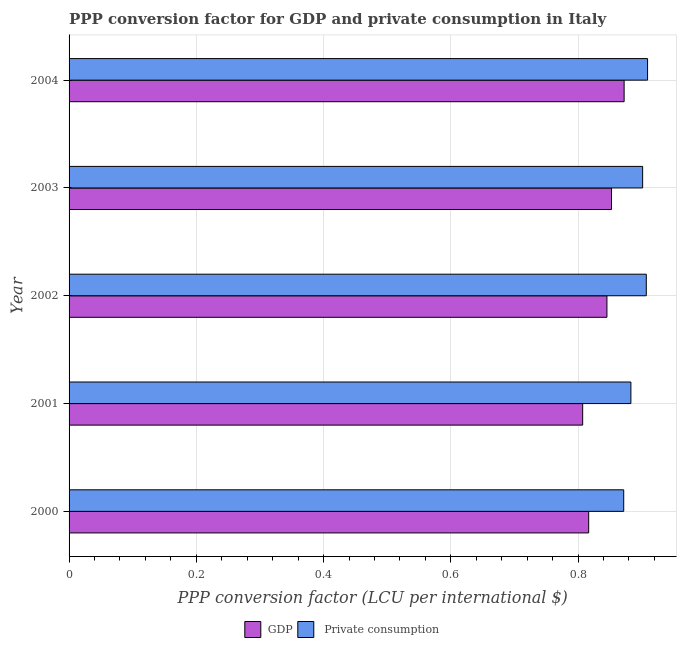Are the number of bars on each tick of the Y-axis equal?
Provide a short and direct response. Yes. How many bars are there on the 5th tick from the top?
Your answer should be very brief. 2. What is the label of the 5th group of bars from the top?
Offer a terse response. 2000. What is the ppp conversion factor for private consumption in 2003?
Make the answer very short. 0.9. Across all years, what is the maximum ppp conversion factor for private consumption?
Offer a very short reply. 0.91. Across all years, what is the minimum ppp conversion factor for gdp?
Ensure brevity in your answer.  0.81. In which year was the ppp conversion factor for private consumption maximum?
Provide a succinct answer. 2004. What is the total ppp conversion factor for gdp in the graph?
Offer a very short reply. 4.19. What is the difference between the ppp conversion factor for gdp in 2001 and that in 2003?
Your answer should be very brief. -0.04. What is the difference between the ppp conversion factor for private consumption in 2003 and the ppp conversion factor for gdp in 2002?
Provide a short and direct response. 0.06. What is the average ppp conversion factor for private consumption per year?
Keep it short and to the point. 0.9. In the year 2003, what is the difference between the ppp conversion factor for private consumption and ppp conversion factor for gdp?
Your response must be concise. 0.05. In how many years, is the ppp conversion factor for gdp greater than 0.7600000000000001 LCU?
Your response must be concise. 5. Is the difference between the ppp conversion factor for private consumption in 2002 and 2004 greater than the difference between the ppp conversion factor for gdp in 2002 and 2004?
Ensure brevity in your answer.  Yes. What is the difference between the highest and the second highest ppp conversion factor for private consumption?
Offer a terse response. 0. Is the sum of the ppp conversion factor for private consumption in 2001 and 2004 greater than the maximum ppp conversion factor for gdp across all years?
Provide a succinct answer. Yes. What does the 1st bar from the top in 2004 represents?
Give a very brief answer.  Private consumption. What does the 1st bar from the bottom in 2000 represents?
Ensure brevity in your answer.  GDP. How many bars are there?
Your answer should be very brief. 10. Are all the bars in the graph horizontal?
Your response must be concise. Yes. What is the difference between two consecutive major ticks on the X-axis?
Give a very brief answer. 0.2. Does the graph contain any zero values?
Provide a succinct answer. No. What is the title of the graph?
Offer a terse response. PPP conversion factor for GDP and private consumption in Italy. What is the label or title of the X-axis?
Your answer should be compact. PPP conversion factor (LCU per international $). What is the PPP conversion factor (LCU per international $) of GDP in 2000?
Offer a terse response. 0.82. What is the PPP conversion factor (LCU per international $) of  Private consumption in 2000?
Provide a succinct answer. 0.87. What is the PPP conversion factor (LCU per international $) of GDP in 2001?
Offer a terse response. 0.81. What is the PPP conversion factor (LCU per international $) in  Private consumption in 2001?
Your answer should be compact. 0.88. What is the PPP conversion factor (LCU per international $) of GDP in 2002?
Your answer should be compact. 0.85. What is the PPP conversion factor (LCU per international $) of  Private consumption in 2002?
Keep it short and to the point. 0.91. What is the PPP conversion factor (LCU per international $) of GDP in 2003?
Your response must be concise. 0.85. What is the PPP conversion factor (LCU per international $) of  Private consumption in 2003?
Give a very brief answer. 0.9. What is the PPP conversion factor (LCU per international $) of GDP in 2004?
Offer a very short reply. 0.87. What is the PPP conversion factor (LCU per international $) in  Private consumption in 2004?
Ensure brevity in your answer.  0.91. Across all years, what is the maximum PPP conversion factor (LCU per international $) of GDP?
Provide a short and direct response. 0.87. Across all years, what is the maximum PPP conversion factor (LCU per international $) in  Private consumption?
Give a very brief answer. 0.91. Across all years, what is the minimum PPP conversion factor (LCU per international $) in GDP?
Give a very brief answer. 0.81. Across all years, what is the minimum PPP conversion factor (LCU per international $) in  Private consumption?
Offer a terse response. 0.87. What is the total PPP conversion factor (LCU per international $) in GDP in the graph?
Make the answer very short. 4.19. What is the total PPP conversion factor (LCU per international $) in  Private consumption in the graph?
Make the answer very short. 4.47. What is the difference between the PPP conversion factor (LCU per international $) of GDP in 2000 and that in 2001?
Your answer should be compact. 0.01. What is the difference between the PPP conversion factor (LCU per international $) of  Private consumption in 2000 and that in 2001?
Keep it short and to the point. -0.01. What is the difference between the PPP conversion factor (LCU per international $) of GDP in 2000 and that in 2002?
Provide a succinct answer. -0.03. What is the difference between the PPP conversion factor (LCU per international $) in  Private consumption in 2000 and that in 2002?
Your answer should be compact. -0.04. What is the difference between the PPP conversion factor (LCU per international $) of GDP in 2000 and that in 2003?
Provide a short and direct response. -0.04. What is the difference between the PPP conversion factor (LCU per international $) of  Private consumption in 2000 and that in 2003?
Offer a very short reply. -0.03. What is the difference between the PPP conversion factor (LCU per international $) in GDP in 2000 and that in 2004?
Provide a succinct answer. -0.06. What is the difference between the PPP conversion factor (LCU per international $) in  Private consumption in 2000 and that in 2004?
Ensure brevity in your answer.  -0.04. What is the difference between the PPP conversion factor (LCU per international $) in GDP in 2001 and that in 2002?
Keep it short and to the point. -0.04. What is the difference between the PPP conversion factor (LCU per international $) of  Private consumption in 2001 and that in 2002?
Offer a terse response. -0.02. What is the difference between the PPP conversion factor (LCU per international $) in GDP in 2001 and that in 2003?
Provide a succinct answer. -0.05. What is the difference between the PPP conversion factor (LCU per international $) of  Private consumption in 2001 and that in 2003?
Provide a succinct answer. -0.02. What is the difference between the PPP conversion factor (LCU per international $) in GDP in 2001 and that in 2004?
Provide a short and direct response. -0.07. What is the difference between the PPP conversion factor (LCU per international $) of  Private consumption in 2001 and that in 2004?
Your response must be concise. -0.03. What is the difference between the PPP conversion factor (LCU per international $) in GDP in 2002 and that in 2003?
Your response must be concise. -0.01. What is the difference between the PPP conversion factor (LCU per international $) in  Private consumption in 2002 and that in 2003?
Provide a succinct answer. 0.01. What is the difference between the PPP conversion factor (LCU per international $) of GDP in 2002 and that in 2004?
Keep it short and to the point. -0.03. What is the difference between the PPP conversion factor (LCU per international $) of  Private consumption in 2002 and that in 2004?
Provide a short and direct response. -0. What is the difference between the PPP conversion factor (LCU per international $) of GDP in 2003 and that in 2004?
Your response must be concise. -0.02. What is the difference between the PPP conversion factor (LCU per international $) of  Private consumption in 2003 and that in 2004?
Offer a terse response. -0.01. What is the difference between the PPP conversion factor (LCU per international $) in GDP in 2000 and the PPP conversion factor (LCU per international $) in  Private consumption in 2001?
Your answer should be very brief. -0.07. What is the difference between the PPP conversion factor (LCU per international $) of GDP in 2000 and the PPP conversion factor (LCU per international $) of  Private consumption in 2002?
Provide a succinct answer. -0.09. What is the difference between the PPP conversion factor (LCU per international $) of GDP in 2000 and the PPP conversion factor (LCU per international $) of  Private consumption in 2003?
Your answer should be very brief. -0.08. What is the difference between the PPP conversion factor (LCU per international $) of GDP in 2000 and the PPP conversion factor (LCU per international $) of  Private consumption in 2004?
Your answer should be very brief. -0.09. What is the difference between the PPP conversion factor (LCU per international $) in GDP in 2001 and the PPP conversion factor (LCU per international $) in  Private consumption in 2002?
Your answer should be compact. -0.1. What is the difference between the PPP conversion factor (LCU per international $) in GDP in 2001 and the PPP conversion factor (LCU per international $) in  Private consumption in 2003?
Offer a very short reply. -0.09. What is the difference between the PPP conversion factor (LCU per international $) of GDP in 2001 and the PPP conversion factor (LCU per international $) of  Private consumption in 2004?
Your response must be concise. -0.1. What is the difference between the PPP conversion factor (LCU per international $) of GDP in 2002 and the PPP conversion factor (LCU per international $) of  Private consumption in 2003?
Make the answer very short. -0.06. What is the difference between the PPP conversion factor (LCU per international $) in GDP in 2002 and the PPP conversion factor (LCU per international $) in  Private consumption in 2004?
Your response must be concise. -0.06. What is the difference between the PPP conversion factor (LCU per international $) of GDP in 2003 and the PPP conversion factor (LCU per international $) of  Private consumption in 2004?
Offer a terse response. -0.06. What is the average PPP conversion factor (LCU per international $) in GDP per year?
Give a very brief answer. 0.84. What is the average PPP conversion factor (LCU per international $) in  Private consumption per year?
Offer a terse response. 0.89. In the year 2000, what is the difference between the PPP conversion factor (LCU per international $) in GDP and PPP conversion factor (LCU per international $) in  Private consumption?
Provide a succinct answer. -0.06. In the year 2001, what is the difference between the PPP conversion factor (LCU per international $) in GDP and PPP conversion factor (LCU per international $) in  Private consumption?
Your answer should be very brief. -0.08. In the year 2002, what is the difference between the PPP conversion factor (LCU per international $) of GDP and PPP conversion factor (LCU per international $) of  Private consumption?
Ensure brevity in your answer.  -0.06. In the year 2003, what is the difference between the PPP conversion factor (LCU per international $) of GDP and PPP conversion factor (LCU per international $) of  Private consumption?
Your answer should be very brief. -0.05. In the year 2004, what is the difference between the PPP conversion factor (LCU per international $) in GDP and PPP conversion factor (LCU per international $) in  Private consumption?
Ensure brevity in your answer.  -0.04. What is the ratio of the PPP conversion factor (LCU per international $) of GDP in 2000 to that in 2001?
Your answer should be very brief. 1.01. What is the ratio of the PPP conversion factor (LCU per international $) in  Private consumption in 2000 to that in 2001?
Your answer should be very brief. 0.99. What is the ratio of the PPP conversion factor (LCU per international $) in GDP in 2000 to that in 2002?
Your answer should be very brief. 0.97. What is the ratio of the PPP conversion factor (LCU per international $) of  Private consumption in 2000 to that in 2002?
Ensure brevity in your answer.  0.96. What is the ratio of the PPP conversion factor (LCU per international $) of GDP in 2000 to that in 2003?
Make the answer very short. 0.96. What is the ratio of the PPP conversion factor (LCU per international $) in GDP in 2000 to that in 2004?
Ensure brevity in your answer.  0.94. What is the ratio of the PPP conversion factor (LCU per international $) of  Private consumption in 2000 to that in 2004?
Provide a short and direct response. 0.96. What is the ratio of the PPP conversion factor (LCU per international $) in GDP in 2001 to that in 2002?
Your response must be concise. 0.95. What is the ratio of the PPP conversion factor (LCU per international $) in  Private consumption in 2001 to that in 2002?
Your response must be concise. 0.97. What is the ratio of the PPP conversion factor (LCU per international $) in GDP in 2001 to that in 2003?
Keep it short and to the point. 0.95. What is the ratio of the PPP conversion factor (LCU per international $) in  Private consumption in 2001 to that in 2003?
Your response must be concise. 0.98. What is the ratio of the PPP conversion factor (LCU per international $) of GDP in 2001 to that in 2004?
Offer a terse response. 0.93. What is the ratio of the PPP conversion factor (LCU per international $) in  Private consumption in 2001 to that in 2004?
Give a very brief answer. 0.97. What is the ratio of the PPP conversion factor (LCU per international $) in GDP in 2002 to that in 2003?
Your response must be concise. 0.99. What is the ratio of the PPP conversion factor (LCU per international $) of  Private consumption in 2002 to that in 2003?
Keep it short and to the point. 1.01. What is the ratio of the PPP conversion factor (LCU per international $) of GDP in 2003 to that in 2004?
Your response must be concise. 0.98. What is the ratio of the PPP conversion factor (LCU per international $) in  Private consumption in 2003 to that in 2004?
Make the answer very short. 0.99. What is the difference between the highest and the second highest PPP conversion factor (LCU per international $) of GDP?
Your answer should be compact. 0.02. What is the difference between the highest and the second highest PPP conversion factor (LCU per international $) of  Private consumption?
Your answer should be compact. 0. What is the difference between the highest and the lowest PPP conversion factor (LCU per international $) in GDP?
Keep it short and to the point. 0.07. What is the difference between the highest and the lowest PPP conversion factor (LCU per international $) of  Private consumption?
Your answer should be very brief. 0.04. 